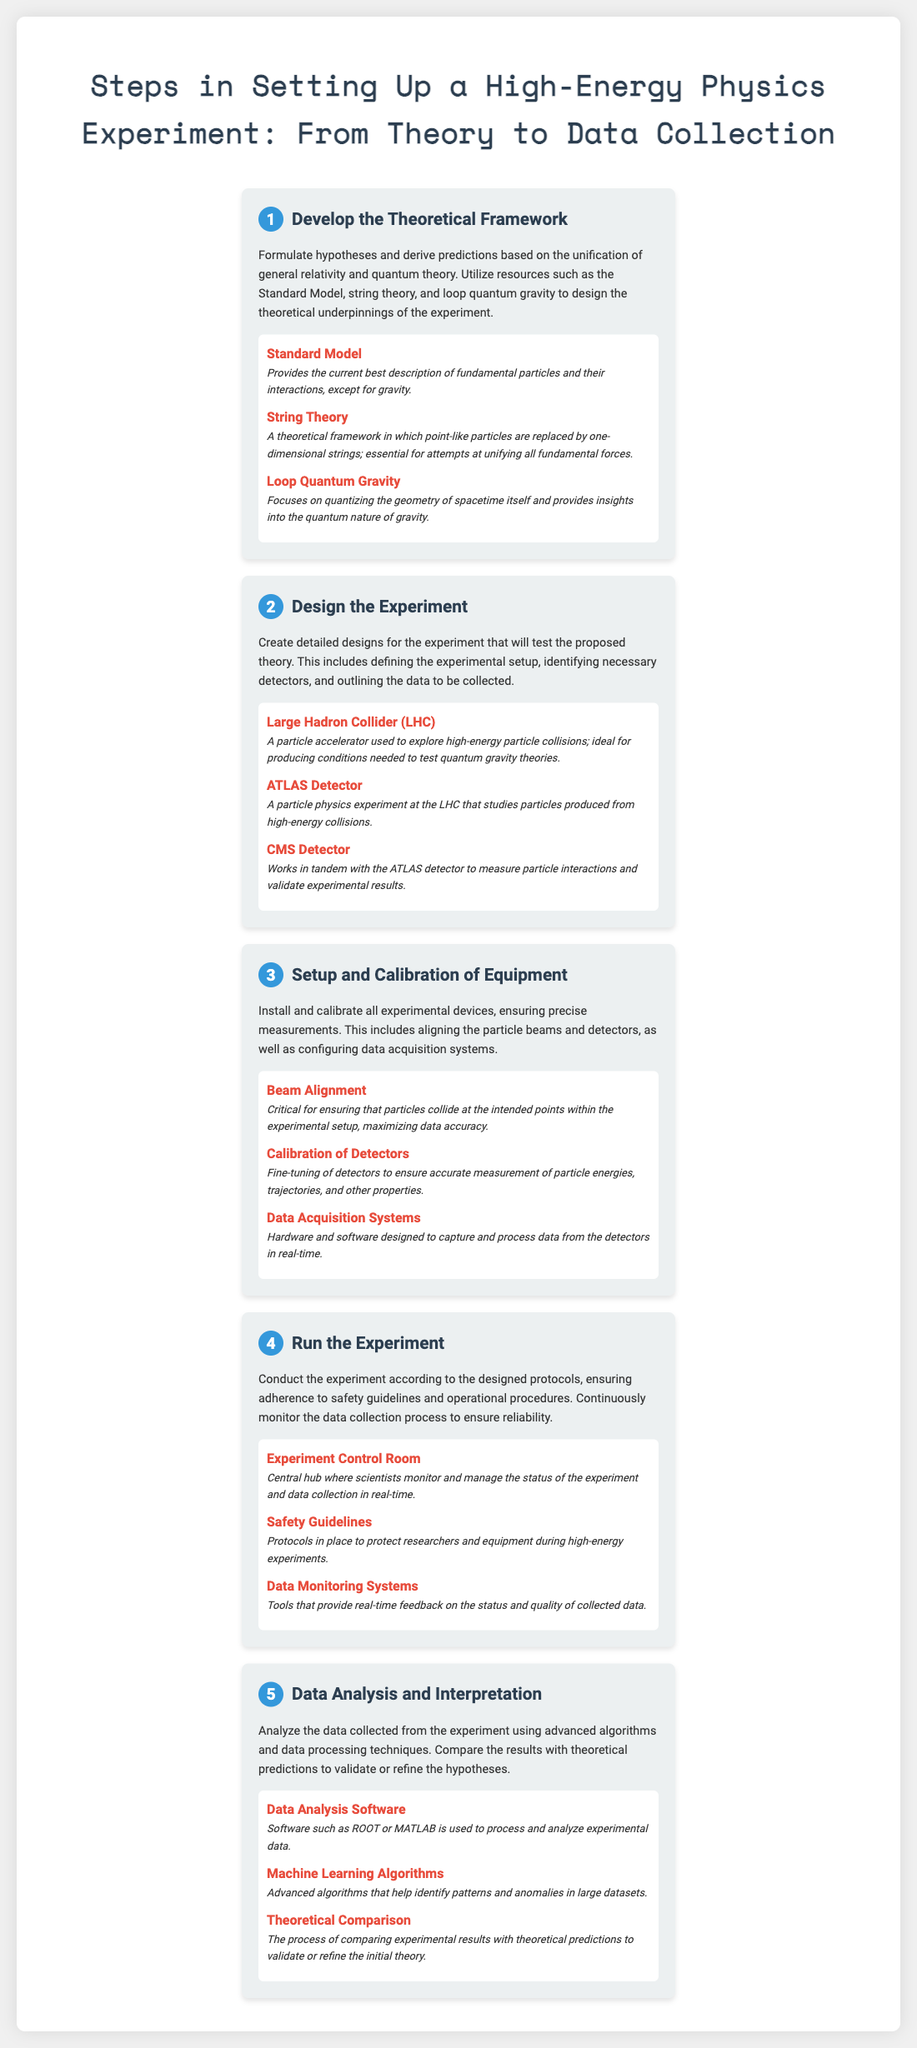what is the first step in setting up a high-energy physics experiment? The first step is "Develop the Theoretical Framework," which involves formulating hypotheses and deriving predictions.
Answer: Develop the Theoretical Framework which theoretical frameworks are mentioned in relation to step one? Theoretical frameworks mentioned include the Standard Model, string theory, and loop quantum gravity.
Answer: Standard Model, string theory, loop quantum gravity what equipment is essential for the experiment design in step two? The essential equipment includes the Large Hadron Collider, ATLAS Detector, and CMS Detector.
Answer: Large Hadron Collider, ATLAS Detector, CMS Detector how many steps are there in total for setting up the experiment? The document outlines a total of five steps in the experimental process.
Answer: Five what is one key aspect of the setup and calibration of equipment? A key aspect is beam alignment, which is critical for ensuring particles collide accurately.
Answer: Beam alignment what type of software is used for data analysis in step five? The document states that data analysis software such as ROOT or MATLAB is used.
Answer: ROOT, MATLAB what is the main focus of the experiment during step four? The main focus is to run the experiment according to designed protocols while ensuring data reliability.
Answer: Run the experiment what role do safety guidelines play in the experiment? Safety guidelines provide protocols to protect researchers and equipment during high-energy experiments.
Answer: Protect researchers and equipment what is compared to validate or refine the hypotheses in data analysis? Experimental results are compared against theoretical predictions to validate or refine the hypotheses.
Answer: Theoretical predictions 